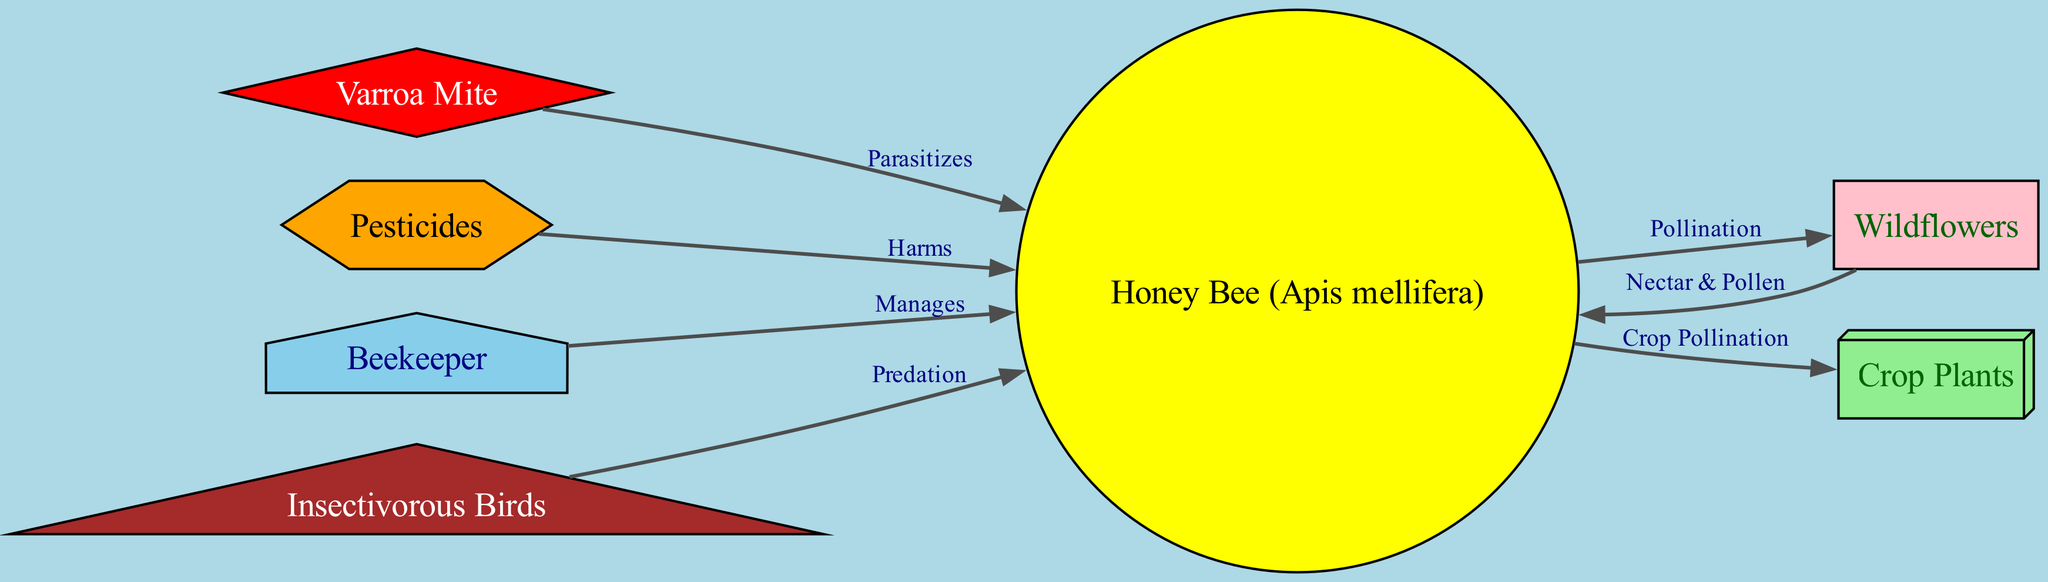What are the primary plants associated with honeybees in this ecosystem? The diagram indicates that honeybees are associated with two types of plants: wildflowers and crop plants. Both nodes directly connect to the honeybee node with labeled edges showing their relationship as sources of nectar and pollen, and for crop pollination respectively.
Answer: Wildflowers, Crop Plants How many edges are there connecting the honeybee node to other organisms? The diagram shows a total of five edges connecting the honeybee to other nodes: wildflowers, crop plants, varroa mites, pesticides, and insectivorous birds. This includes both beneficial relationships like pollination and harmful interactions like predation and parasitism.
Answer: 5 Which organism poses a predatory threat to honeybees? Checking the diagram reveals that the insectivorous birds node has an edge directed towards the honeybee node labeled "Predation." This clearly indicates that they are a predator of honeybees in this ecosystem setup.
Answer: Insectivorous Birds What is the role of the beekeeper in the ecosystem? The beekeeper node is connected to the honeybee node with an edge labeled "Manages." This suggests that the beekeeper plays a significant role in the maintenance and care of honeybee populations, which is crucial for their survival and productivity.
Answer: Manages Which organism directly harms honeybees according to the diagram? The edge from the pesticide node to the honeybee node is labeled "Harms," indicating that pesticides are a direct threat to honeybees, negatively impacting their health and population.
Answer: Pesticides How many types of plants are shown in the ecosystem map? The diagram includes two distinct types of plants that honeybees interact with: wildflowers and crop plants. Both nodes are connected to the honeybee, providing food sources for them.
Answer: 2 What type of relationship exists between honeybees and wildflowers? The edge connecting the honeybee to the wildflower node is labeled "Pollination." This implies a mutualistic relationship where honeybees help pollinate wildflowers while receiving nectar and pollen as food.
Answer: Pollination What are the color representations of the 'Varroa Mite' node in the diagram? The visualization represents the varroa mite node using a diamond shape filled with red color and white font. This color choice might signify danger or harmfulness, reflecting its role as a parasite to honeybees in the diagram.
Answer: Red What shape is used to depict the honeybee in the diagram? The honeybee node is depicted using a circular shape filled with yellow color, a design choice that likely emphasizes its importance and friendly association with the ecosystem as a pollinator.
Answer: Circle 